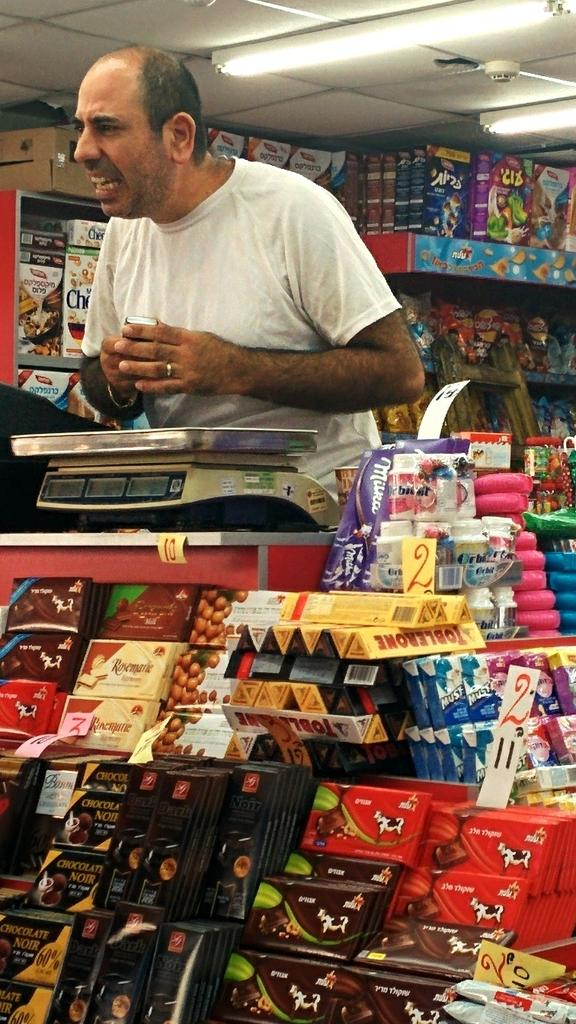Who is present in the image? There is a man in the image. What is the man using in the image? The man is using a measuring machine in the image. What else can be seen in the image besides the man and the measuring machine? There are products in the image. How does the man balance the products on his head in the image? There is no indication in the image that the man is balancing products on his head. 